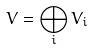<formula> <loc_0><loc_0><loc_500><loc_500>V = \bigoplus _ { i } V _ { i }</formula> 